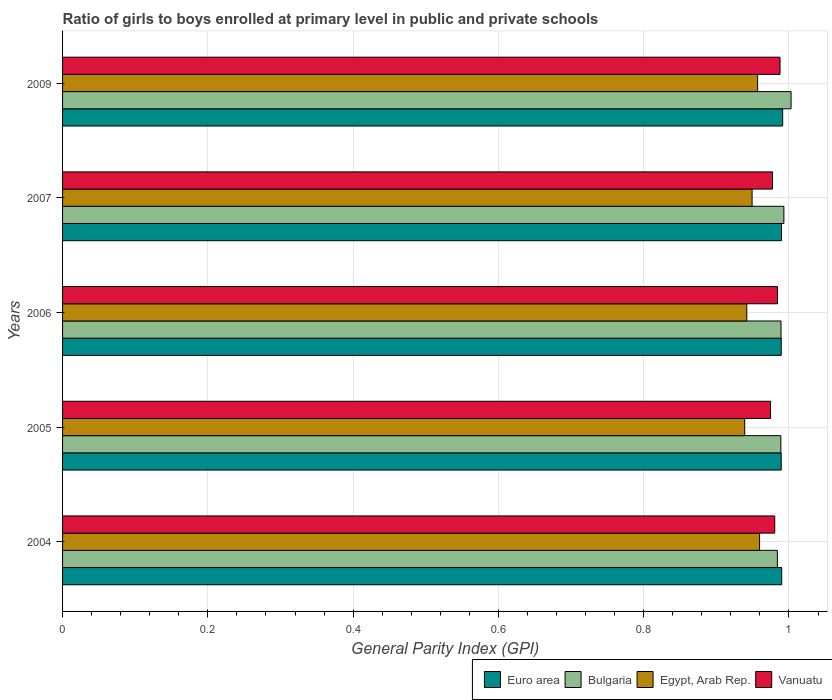How many groups of bars are there?
Offer a very short reply. 5. Are the number of bars per tick equal to the number of legend labels?
Your answer should be very brief. Yes. Are the number of bars on each tick of the Y-axis equal?
Keep it short and to the point. Yes. In how many cases, is the number of bars for a given year not equal to the number of legend labels?
Offer a terse response. 0. What is the general parity index in Bulgaria in 2007?
Your answer should be compact. 0.99. Across all years, what is the maximum general parity index in Euro area?
Offer a terse response. 0.99. Across all years, what is the minimum general parity index in Euro area?
Make the answer very short. 0.99. In which year was the general parity index in Vanuatu minimum?
Provide a short and direct response. 2005. What is the total general parity index in Egypt, Arab Rep. in the graph?
Provide a short and direct response. 4.75. What is the difference between the general parity index in Euro area in 2004 and that in 2009?
Ensure brevity in your answer.  -0. What is the difference between the general parity index in Vanuatu in 2006 and the general parity index in Bulgaria in 2007?
Provide a short and direct response. -0.01. What is the average general parity index in Euro area per year?
Provide a succinct answer. 0.99. In the year 2009, what is the difference between the general parity index in Bulgaria and general parity index in Euro area?
Your answer should be compact. 0.01. In how many years, is the general parity index in Euro area greater than 0.56 ?
Give a very brief answer. 5. What is the ratio of the general parity index in Bulgaria in 2004 to that in 2007?
Provide a succinct answer. 0.99. Is the difference between the general parity index in Bulgaria in 2005 and 2009 greater than the difference between the general parity index in Euro area in 2005 and 2009?
Ensure brevity in your answer.  No. What is the difference between the highest and the second highest general parity index in Bulgaria?
Offer a terse response. 0.01. What is the difference between the highest and the lowest general parity index in Vanuatu?
Your answer should be compact. 0.01. In how many years, is the general parity index in Egypt, Arab Rep. greater than the average general parity index in Egypt, Arab Rep. taken over all years?
Offer a terse response. 2. Is the sum of the general parity index in Bulgaria in 2004 and 2007 greater than the maximum general parity index in Egypt, Arab Rep. across all years?
Offer a very short reply. Yes. Is it the case that in every year, the sum of the general parity index in Bulgaria and general parity index in Egypt, Arab Rep. is greater than the sum of general parity index in Vanuatu and general parity index in Euro area?
Offer a terse response. No. What does the 1st bar from the top in 2005 represents?
Your answer should be very brief. Vanuatu. What does the 2nd bar from the bottom in 2006 represents?
Offer a very short reply. Bulgaria. Are all the bars in the graph horizontal?
Keep it short and to the point. Yes. What is the difference between two consecutive major ticks on the X-axis?
Ensure brevity in your answer.  0.2. Does the graph contain any zero values?
Your response must be concise. No. Does the graph contain grids?
Give a very brief answer. Yes. How many legend labels are there?
Ensure brevity in your answer.  4. What is the title of the graph?
Ensure brevity in your answer.  Ratio of girls to boys enrolled at primary level in public and private schools. Does "Korea (Democratic)" appear as one of the legend labels in the graph?
Offer a very short reply. No. What is the label or title of the X-axis?
Keep it short and to the point. General Parity Index (GPI). What is the General Parity Index (GPI) of Euro area in 2004?
Offer a very short reply. 0.99. What is the General Parity Index (GPI) of Bulgaria in 2004?
Provide a short and direct response. 0.98. What is the General Parity Index (GPI) of Egypt, Arab Rep. in 2004?
Offer a very short reply. 0.96. What is the General Parity Index (GPI) in Vanuatu in 2004?
Make the answer very short. 0.98. What is the General Parity Index (GPI) in Euro area in 2005?
Provide a succinct answer. 0.99. What is the General Parity Index (GPI) in Bulgaria in 2005?
Ensure brevity in your answer.  0.99. What is the General Parity Index (GPI) of Egypt, Arab Rep. in 2005?
Offer a very short reply. 0.94. What is the General Parity Index (GPI) in Vanuatu in 2005?
Give a very brief answer. 0.97. What is the General Parity Index (GPI) in Euro area in 2006?
Your response must be concise. 0.99. What is the General Parity Index (GPI) of Bulgaria in 2006?
Your answer should be very brief. 0.99. What is the General Parity Index (GPI) of Egypt, Arab Rep. in 2006?
Your answer should be compact. 0.94. What is the General Parity Index (GPI) in Vanuatu in 2006?
Your answer should be very brief. 0.98. What is the General Parity Index (GPI) in Euro area in 2007?
Ensure brevity in your answer.  0.99. What is the General Parity Index (GPI) of Bulgaria in 2007?
Your answer should be very brief. 0.99. What is the General Parity Index (GPI) of Egypt, Arab Rep. in 2007?
Your answer should be very brief. 0.95. What is the General Parity Index (GPI) of Vanuatu in 2007?
Your answer should be very brief. 0.98. What is the General Parity Index (GPI) of Euro area in 2009?
Offer a terse response. 0.99. What is the General Parity Index (GPI) of Bulgaria in 2009?
Offer a very short reply. 1. What is the General Parity Index (GPI) of Egypt, Arab Rep. in 2009?
Your response must be concise. 0.96. What is the General Parity Index (GPI) of Vanuatu in 2009?
Make the answer very short. 0.99. Across all years, what is the maximum General Parity Index (GPI) in Euro area?
Your response must be concise. 0.99. Across all years, what is the maximum General Parity Index (GPI) of Bulgaria?
Make the answer very short. 1. Across all years, what is the maximum General Parity Index (GPI) in Egypt, Arab Rep.?
Give a very brief answer. 0.96. Across all years, what is the maximum General Parity Index (GPI) of Vanuatu?
Offer a terse response. 0.99. Across all years, what is the minimum General Parity Index (GPI) of Euro area?
Make the answer very short. 0.99. Across all years, what is the minimum General Parity Index (GPI) in Bulgaria?
Your response must be concise. 0.98. Across all years, what is the minimum General Parity Index (GPI) in Egypt, Arab Rep.?
Provide a succinct answer. 0.94. Across all years, what is the minimum General Parity Index (GPI) of Vanuatu?
Give a very brief answer. 0.97. What is the total General Parity Index (GPI) of Euro area in the graph?
Your answer should be compact. 4.95. What is the total General Parity Index (GPI) in Bulgaria in the graph?
Your response must be concise. 4.96. What is the total General Parity Index (GPI) of Egypt, Arab Rep. in the graph?
Your answer should be very brief. 4.75. What is the total General Parity Index (GPI) in Vanuatu in the graph?
Keep it short and to the point. 4.9. What is the difference between the General Parity Index (GPI) in Euro area in 2004 and that in 2005?
Make the answer very short. 0. What is the difference between the General Parity Index (GPI) in Bulgaria in 2004 and that in 2005?
Give a very brief answer. -0. What is the difference between the General Parity Index (GPI) in Egypt, Arab Rep. in 2004 and that in 2005?
Keep it short and to the point. 0.02. What is the difference between the General Parity Index (GPI) in Vanuatu in 2004 and that in 2005?
Offer a terse response. 0.01. What is the difference between the General Parity Index (GPI) of Euro area in 2004 and that in 2006?
Make the answer very short. 0. What is the difference between the General Parity Index (GPI) in Bulgaria in 2004 and that in 2006?
Your answer should be compact. -0.01. What is the difference between the General Parity Index (GPI) in Egypt, Arab Rep. in 2004 and that in 2006?
Your answer should be compact. 0.02. What is the difference between the General Parity Index (GPI) in Vanuatu in 2004 and that in 2006?
Your response must be concise. -0. What is the difference between the General Parity Index (GPI) in Bulgaria in 2004 and that in 2007?
Keep it short and to the point. -0.01. What is the difference between the General Parity Index (GPI) in Egypt, Arab Rep. in 2004 and that in 2007?
Make the answer very short. 0.01. What is the difference between the General Parity Index (GPI) in Vanuatu in 2004 and that in 2007?
Keep it short and to the point. 0. What is the difference between the General Parity Index (GPI) in Euro area in 2004 and that in 2009?
Your answer should be very brief. -0. What is the difference between the General Parity Index (GPI) of Bulgaria in 2004 and that in 2009?
Your answer should be very brief. -0.02. What is the difference between the General Parity Index (GPI) of Egypt, Arab Rep. in 2004 and that in 2009?
Ensure brevity in your answer.  0. What is the difference between the General Parity Index (GPI) in Vanuatu in 2004 and that in 2009?
Your answer should be compact. -0.01. What is the difference between the General Parity Index (GPI) in Euro area in 2005 and that in 2006?
Offer a terse response. -0. What is the difference between the General Parity Index (GPI) in Bulgaria in 2005 and that in 2006?
Keep it short and to the point. -0. What is the difference between the General Parity Index (GPI) in Egypt, Arab Rep. in 2005 and that in 2006?
Offer a very short reply. -0. What is the difference between the General Parity Index (GPI) of Vanuatu in 2005 and that in 2006?
Give a very brief answer. -0.01. What is the difference between the General Parity Index (GPI) in Euro area in 2005 and that in 2007?
Make the answer very short. -0. What is the difference between the General Parity Index (GPI) in Bulgaria in 2005 and that in 2007?
Make the answer very short. -0. What is the difference between the General Parity Index (GPI) in Egypt, Arab Rep. in 2005 and that in 2007?
Give a very brief answer. -0.01. What is the difference between the General Parity Index (GPI) of Vanuatu in 2005 and that in 2007?
Your answer should be compact. -0. What is the difference between the General Parity Index (GPI) of Euro area in 2005 and that in 2009?
Provide a short and direct response. -0. What is the difference between the General Parity Index (GPI) of Bulgaria in 2005 and that in 2009?
Your answer should be compact. -0.01. What is the difference between the General Parity Index (GPI) in Egypt, Arab Rep. in 2005 and that in 2009?
Your response must be concise. -0.02. What is the difference between the General Parity Index (GPI) of Vanuatu in 2005 and that in 2009?
Offer a terse response. -0.01. What is the difference between the General Parity Index (GPI) in Euro area in 2006 and that in 2007?
Make the answer very short. -0. What is the difference between the General Parity Index (GPI) of Bulgaria in 2006 and that in 2007?
Offer a terse response. -0. What is the difference between the General Parity Index (GPI) of Egypt, Arab Rep. in 2006 and that in 2007?
Offer a very short reply. -0.01. What is the difference between the General Parity Index (GPI) of Vanuatu in 2006 and that in 2007?
Your answer should be very brief. 0.01. What is the difference between the General Parity Index (GPI) of Euro area in 2006 and that in 2009?
Offer a very short reply. -0. What is the difference between the General Parity Index (GPI) of Bulgaria in 2006 and that in 2009?
Keep it short and to the point. -0.01. What is the difference between the General Parity Index (GPI) of Egypt, Arab Rep. in 2006 and that in 2009?
Provide a succinct answer. -0.01. What is the difference between the General Parity Index (GPI) of Vanuatu in 2006 and that in 2009?
Offer a very short reply. -0. What is the difference between the General Parity Index (GPI) of Euro area in 2007 and that in 2009?
Provide a short and direct response. -0. What is the difference between the General Parity Index (GPI) of Bulgaria in 2007 and that in 2009?
Provide a succinct answer. -0.01. What is the difference between the General Parity Index (GPI) of Egypt, Arab Rep. in 2007 and that in 2009?
Provide a short and direct response. -0.01. What is the difference between the General Parity Index (GPI) of Vanuatu in 2007 and that in 2009?
Your answer should be very brief. -0.01. What is the difference between the General Parity Index (GPI) of Euro area in 2004 and the General Parity Index (GPI) of Bulgaria in 2005?
Make the answer very short. 0. What is the difference between the General Parity Index (GPI) in Euro area in 2004 and the General Parity Index (GPI) in Egypt, Arab Rep. in 2005?
Ensure brevity in your answer.  0.05. What is the difference between the General Parity Index (GPI) in Euro area in 2004 and the General Parity Index (GPI) in Vanuatu in 2005?
Make the answer very short. 0.02. What is the difference between the General Parity Index (GPI) of Bulgaria in 2004 and the General Parity Index (GPI) of Egypt, Arab Rep. in 2005?
Offer a terse response. 0.04. What is the difference between the General Parity Index (GPI) of Bulgaria in 2004 and the General Parity Index (GPI) of Vanuatu in 2005?
Keep it short and to the point. 0.01. What is the difference between the General Parity Index (GPI) of Egypt, Arab Rep. in 2004 and the General Parity Index (GPI) of Vanuatu in 2005?
Keep it short and to the point. -0.02. What is the difference between the General Parity Index (GPI) in Euro area in 2004 and the General Parity Index (GPI) in Bulgaria in 2006?
Your response must be concise. 0. What is the difference between the General Parity Index (GPI) in Euro area in 2004 and the General Parity Index (GPI) in Egypt, Arab Rep. in 2006?
Ensure brevity in your answer.  0.05. What is the difference between the General Parity Index (GPI) of Euro area in 2004 and the General Parity Index (GPI) of Vanuatu in 2006?
Provide a short and direct response. 0.01. What is the difference between the General Parity Index (GPI) in Bulgaria in 2004 and the General Parity Index (GPI) in Egypt, Arab Rep. in 2006?
Your answer should be compact. 0.04. What is the difference between the General Parity Index (GPI) in Bulgaria in 2004 and the General Parity Index (GPI) in Vanuatu in 2006?
Your answer should be very brief. -0. What is the difference between the General Parity Index (GPI) in Egypt, Arab Rep. in 2004 and the General Parity Index (GPI) in Vanuatu in 2006?
Offer a terse response. -0.02. What is the difference between the General Parity Index (GPI) of Euro area in 2004 and the General Parity Index (GPI) of Bulgaria in 2007?
Keep it short and to the point. -0. What is the difference between the General Parity Index (GPI) of Euro area in 2004 and the General Parity Index (GPI) of Egypt, Arab Rep. in 2007?
Your response must be concise. 0.04. What is the difference between the General Parity Index (GPI) of Euro area in 2004 and the General Parity Index (GPI) of Vanuatu in 2007?
Your answer should be very brief. 0.01. What is the difference between the General Parity Index (GPI) in Bulgaria in 2004 and the General Parity Index (GPI) in Egypt, Arab Rep. in 2007?
Ensure brevity in your answer.  0.03. What is the difference between the General Parity Index (GPI) in Bulgaria in 2004 and the General Parity Index (GPI) in Vanuatu in 2007?
Your answer should be compact. 0.01. What is the difference between the General Parity Index (GPI) of Egypt, Arab Rep. in 2004 and the General Parity Index (GPI) of Vanuatu in 2007?
Offer a terse response. -0.02. What is the difference between the General Parity Index (GPI) in Euro area in 2004 and the General Parity Index (GPI) in Bulgaria in 2009?
Your answer should be very brief. -0.01. What is the difference between the General Parity Index (GPI) in Euro area in 2004 and the General Parity Index (GPI) in Egypt, Arab Rep. in 2009?
Your answer should be compact. 0.03. What is the difference between the General Parity Index (GPI) in Euro area in 2004 and the General Parity Index (GPI) in Vanuatu in 2009?
Offer a terse response. 0. What is the difference between the General Parity Index (GPI) in Bulgaria in 2004 and the General Parity Index (GPI) in Egypt, Arab Rep. in 2009?
Ensure brevity in your answer.  0.03. What is the difference between the General Parity Index (GPI) of Bulgaria in 2004 and the General Parity Index (GPI) of Vanuatu in 2009?
Make the answer very short. -0. What is the difference between the General Parity Index (GPI) of Egypt, Arab Rep. in 2004 and the General Parity Index (GPI) of Vanuatu in 2009?
Make the answer very short. -0.03. What is the difference between the General Parity Index (GPI) in Euro area in 2005 and the General Parity Index (GPI) in Bulgaria in 2006?
Make the answer very short. 0. What is the difference between the General Parity Index (GPI) of Euro area in 2005 and the General Parity Index (GPI) of Egypt, Arab Rep. in 2006?
Make the answer very short. 0.05. What is the difference between the General Parity Index (GPI) in Euro area in 2005 and the General Parity Index (GPI) in Vanuatu in 2006?
Provide a short and direct response. 0.01. What is the difference between the General Parity Index (GPI) of Bulgaria in 2005 and the General Parity Index (GPI) of Egypt, Arab Rep. in 2006?
Your answer should be compact. 0.05. What is the difference between the General Parity Index (GPI) of Bulgaria in 2005 and the General Parity Index (GPI) of Vanuatu in 2006?
Your answer should be compact. 0. What is the difference between the General Parity Index (GPI) of Egypt, Arab Rep. in 2005 and the General Parity Index (GPI) of Vanuatu in 2006?
Offer a terse response. -0.05. What is the difference between the General Parity Index (GPI) of Euro area in 2005 and the General Parity Index (GPI) of Bulgaria in 2007?
Provide a short and direct response. -0. What is the difference between the General Parity Index (GPI) of Euro area in 2005 and the General Parity Index (GPI) of Egypt, Arab Rep. in 2007?
Make the answer very short. 0.04. What is the difference between the General Parity Index (GPI) of Euro area in 2005 and the General Parity Index (GPI) of Vanuatu in 2007?
Give a very brief answer. 0.01. What is the difference between the General Parity Index (GPI) of Bulgaria in 2005 and the General Parity Index (GPI) of Egypt, Arab Rep. in 2007?
Offer a terse response. 0.04. What is the difference between the General Parity Index (GPI) in Bulgaria in 2005 and the General Parity Index (GPI) in Vanuatu in 2007?
Your response must be concise. 0.01. What is the difference between the General Parity Index (GPI) of Egypt, Arab Rep. in 2005 and the General Parity Index (GPI) of Vanuatu in 2007?
Your answer should be very brief. -0.04. What is the difference between the General Parity Index (GPI) in Euro area in 2005 and the General Parity Index (GPI) in Bulgaria in 2009?
Provide a short and direct response. -0.01. What is the difference between the General Parity Index (GPI) in Euro area in 2005 and the General Parity Index (GPI) in Egypt, Arab Rep. in 2009?
Offer a very short reply. 0.03. What is the difference between the General Parity Index (GPI) of Euro area in 2005 and the General Parity Index (GPI) of Vanuatu in 2009?
Make the answer very short. 0. What is the difference between the General Parity Index (GPI) of Bulgaria in 2005 and the General Parity Index (GPI) of Egypt, Arab Rep. in 2009?
Your response must be concise. 0.03. What is the difference between the General Parity Index (GPI) of Bulgaria in 2005 and the General Parity Index (GPI) of Vanuatu in 2009?
Your response must be concise. 0. What is the difference between the General Parity Index (GPI) in Egypt, Arab Rep. in 2005 and the General Parity Index (GPI) in Vanuatu in 2009?
Offer a terse response. -0.05. What is the difference between the General Parity Index (GPI) of Euro area in 2006 and the General Parity Index (GPI) of Bulgaria in 2007?
Offer a terse response. -0. What is the difference between the General Parity Index (GPI) in Euro area in 2006 and the General Parity Index (GPI) in Egypt, Arab Rep. in 2007?
Give a very brief answer. 0.04. What is the difference between the General Parity Index (GPI) in Euro area in 2006 and the General Parity Index (GPI) in Vanuatu in 2007?
Ensure brevity in your answer.  0.01. What is the difference between the General Parity Index (GPI) of Bulgaria in 2006 and the General Parity Index (GPI) of Egypt, Arab Rep. in 2007?
Your answer should be very brief. 0.04. What is the difference between the General Parity Index (GPI) of Bulgaria in 2006 and the General Parity Index (GPI) of Vanuatu in 2007?
Make the answer very short. 0.01. What is the difference between the General Parity Index (GPI) in Egypt, Arab Rep. in 2006 and the General Parity Index (GPI) in Vanuatu in 2007?
Your answer should be very brief. -0.04. What is the difference between the General Parity Index (GPI) of Euro area in 2006 and the General Parity Index (GPI) of Bulgaria in 2009?
Keep it short and to the point. -0.01. What is the difference between the General Parity Index (GPI) of Euro area in 2006 and the General Parity Index (GPI) of Egypt, Arab Rep. in 2009?
Make the answer very short. 0.03. What is the difference between the General Parity Index (GPI) of Euro area in 2006 and the General Parity Index (GPI) of Vanuatu in 2009?
Provide a succinct answer. 0. What is the difference between the General Parity Index (GPI) in Bulgaria in 2006 and the General Parity Index (GPI) in Egypt, Arab Rep. in 2009?
Give a very brief answer. 0.03. What is the difference between the General Parity Index (GPI) in Bulgaria in 2006 and the General Parity Index (GPI) in Vanuatu in 2009?
Give a very brief answer. 0. What is the difference between the General Parity Index (GPI) in Egypt, Arab Rep. in 2006 and the General Parity Index (GPI) in Vanuatu in 2009?
Give a very brief answer. -0.05. What is the difference between the General Parity Index (GPI) in Euro area in 2007 and the General Parity Index (GPI) in Bulgaria in 2009?
Offer a terse response. -0.01. What is the difference between the General Parity Index (GPI) of Euro area in 2007 and the General Parity Index (GPI) of Egypt, Arab Rep. in 2009?
Give a very brief answer. 0.03. What is the difference between the General Parity Index (GPI) of Euro area in 2007 and the General Parity Index (GPI) of Vanuatu in 2009?
Offer a terse response. 0. What is the difference between the General Parity Index (GPI) in Bulgaria in 2007 and the General Parity Index (GPI) in Egypt, Arab Rep. in 2009?
Provide a short and direct response. 0.04. What is the difference between the General Parity Index (GPI) in Bulgaria in 2007 and the General Parity Index (GPI) in Vanuatu in 2009?
Your response must be concise. 0.01. What is the difference between the General Parity Index (GPI) in Egypt, Arab Rep. in 2007 and the General Parity Index (GPI) in Vanuatu in 2009?
Provide a succinct answer. -0.04. What is the average General Parity Index (GPI) of Euro area per year?
Keep it short and to the point. 0.99. What is the average General Parity Index (GPI) of Bulgaria per year?
Offer a very short reply. 0.99. What is the average General Parity Index (GPI) in Egypt, Arab Rep. per year?
Provide a succinct answer. 0.95. What is the average General Parity Index (GPI) of Vanuatu per year?
Your answer should be very brief. 0.98. In the year 2004, what is the difference between the General Parity Index (GPI) of Euro area and General Parity Index (GPI) of Bulgaria?
Give a very brief answer. 0.01. In the year 2004, what is the difference between the General Parity Index (GPI) of Euro area and General Parity Index (GPI) of Egypt, Arab Rep.?
Ensure brevity in your answer.  0.03. In the year 2004, what is the difference between the General Parity Index (GPI) of Euro area and General Parity Index (GPI) of Vanuatu?
Your response must be concise. 0.01. In the year 2004, what is the difference between the General Parity Index (GPI) of Bulgaria and General Parity Index (GPI) of Egypt, Arab Rep.?
Keep it short and to the point. 0.02. In the year 2004, what is the difference between the General Parity Index (GPI) in Bulgaria and General Parity Index (GPI) in Vanuatu?
Ensure brevity in your answer.  0. In the year 2004, what is the difference between the General Parity Index (GPI) of Egypt, Arab Rep. and General Parity Index (GPI) of Vanuatu?
Give a very brief answer. -0.02. In the year 2005, what is the difference between the General Parity Index (GPI) in Euro area and General Parity Index (GPI) in Bulgaria?
Your response must be concise. 0. In the year 2005, what is the difference between the General Parity Index (GPI) in Euro area and General Parity Index (GPI) in Egypt, Arab Rep.?
Your answer should be compact. 0.05. In the year 2005, what is the difference between the General Parity Index (GPI) in Euro area and General Parity Index (GPI) in Vanuatu?
Your answer should be very brief. 0.01. In the year 2005, what is the difference between the General Parity Index (GPI) of Bulgaria and General Parity Index (GPI) of Egypt, Arab Rep.?
Provide a succinct answer. 0.05. In the year 2005, what is the difference between the General Parity Index (GPI) of Bulgaria and General Parity Index (GPI) of Vanuatu?
Ensure brevity in your answer.  0.01. In the year 2005, what is the difference between the General Parity Index (GPI) of Egypt, Arab Rep. and General Parity Index (GPI) of Vanuatu?
Offer a very short reply. -0.04. In the year 2006, what is the difference between the General Parity Index (GPI) of Euro area and General Parity Index (GPI) of Egypt, Arab Rep.?
Provide a succinct answer. 0.05. In the year 2006, what is the difference between the General Parity Index (GPI) of Euro area and General Parity Index (GPI) of Vanuatu?
Offer a terse response. 0.01. In the year 2006, what is the difference between the General Parity Index (GPI) in Bulgaria and General Parity Index (GPI) in Egypt, Arab Rep.?
Offer a very short reply. 0.05. In the year 2006, what is the difference between the General Parity Index (GPI) of Bulgaria and General Parity Index (GPI) of Vanuatu?
Offer a terse response. 0. In the year 2006, what is the difference between the General Parity Index (GPI) of Egypt, Arab Rep. and General Parity Index (GPI) of Vanuatu?
Your answer should be compact. -0.04. In the year 2007, what is the difference between the General Parity Index (GPI) of Euro area and General Parity Index (GPI) of Bulgaria?
Your answer should be very brief. -0. In the year 2007, what is the difference between the General Parity Index (GPI) in Euro area and General Parity Index (GPI) in Egypt, Arab Rep.?
Keep it short and to the point. 0.04. In the year 2007, what is the difference between the General Parity Index (GPI) of Euro area and General Parity Index (GPI) of Vanuatu?
Make the answer very short. 0.01. In the year 2007, what is the difference between the General Parity Index (GPI) of Bulgaria and General Parity Index (GPI) of Egypt, Arab Rep.?
Offer a terse response. 0.04. In the year 2007, what is the difference between the General Parity Index (GPI) of Bulgaria and General Parity Index (GPI) of Vanuatu?
Your answer should be very brief. 0.02. In the year 2007, what is the difference between the General Parity Index (GPI) in Egypt, Arab Rep. and General Parity Index (GPI) in Vanuatu?
Your answer should be compact. -0.03. In the year 2009, what is the difference between the General Parity Index (GPI) in Euro area and General Parity Index (GPI) in Bulgaria?
Offer a very short reply. -0.01. In the year 2009, what is the difference between the General Parity Index (GPI) in Euro area and General Parity Index (GPI) in Egypt, Arab Rep.?
Offer a terse response. 0.03. In the year 2009, what is the difference between the General Parity Index (GPI) in Euro area and General Parity Index (GPI) in Vanuatu?
Offer a very short reply. 0. In the year 2009, what is the difference between the General Parity Index (GPI) in Bulgaria and General Parity Index (GPI) in Egypt, Arab Rep.?
Your answer should be very brief. 0.05. In the year 2009, what is the difference between the General Parity Index (GPI) in Bulgaria and General Parity Index (GPI) in Vanuatu?
Your response must be concise. 0.02. In the year 2009, what is the difference between the General Parity Index (GPI) in Egypt, Arab Rep. and General Parity Index (GPI) in Vanuatu?
Give a very brief answer. -0.03. What is the ratio of the General Parity Index (GPI) of Euro area in 2004 to that in 2005?
Make the answer very short. 1. What is the ratio of the General Parity Index (GPI) in Bulgaria in 2004 to that in 2005?
Offer a terse response. 1. What is the ratio of the General Parity Index (GPI) of Egypt, Arab Rep. in 2004 to that in 2005?
Make the answer very short. 1.02. What is the ratio of the General Parity Index (GPI) of Vanuatu in 2004 to that in 2005?
Your answer should be very brief. 1.01. What is the ratio of the General Parity Index (GPI) in Euro area in 2004 to that in 2006?
Give a very brief answer. 1. What is the ratio of the General Parity Index (GPI) of Egypt, Arab Rep. in 2004 to that in 2006?
Keep it short and to the point. 1.02. What is the ratio of the General Parity Index (GPI) of Vanuatu in 2004 to that in 2006?
Keep it short and to the point. 1. What is the ratio of the General Parity Index (GPI) of Euro area in 2004 to that in 2007?
Ensure brevity in your answer.  1. What is the ratio of the General Parity Index (GPI) in Egypt, Arab Rep. in 2004 to that in 2007?
Make the answer very short. 1.01. What is the ratio of the General Parity Index (GPI) in Vanuatu in 2004 to that in 2007?
Provide a short and direct response. 1. What is the ratio of the General Parity Index (GPI) in Euro area in 2004 to that in 2009?
Keep it short and to the point. 1. What is the ratio of the General Parity Index (GPI) of Bulgaria in 2004 to that in 2009?
Keep it short and to the point. 0.98. What is the ratio of the General Parity Index (GPI) in Vanuatu in 2004 to that in 2009?
Offer a very short reply. 0.99. What is the ratio of the General Parity Index (GPI) of Euro area in 2005 to that in 2006?
Provide a short and direct response. 1. What is the ratio of the General Parity Index (GPI) in Vanuatu in 2005 to that in 2006?
Make the answer very short. 0.99. What is the ratio of the General Parity Index (GPI) in Euro area in 2005 to that in 2007?
Provide a short and direct response. 1. What is the ratio of the General Parity Index (GPI) of Egypt, Arab Rep. in 2005 to that in 2007?
Give a very brief answer. 0.99. What is the ratio of the General Parity Index (GPI) in Vanuatu in 2005 to that in 2007?
Your answer should be very brief. 1. What is the ratio of the General Parity Index (GPI) of Euro area in 2005 to that in 2009?
Offer a very short reply. 1. What is the ratio of the General Parity Index (GPI) of Bulgaria in 2005 to that in 2009?
Provide a succinct answer. 0.99. What is the ratio of the General Parity Index (GPI) in Egypt, Arab Rep. in 2005 to that in 2009?
Make the answer very short. 0.98. What is the ratio of the General Parity Index (GPI) in Bulgaria in 2006 to that in 2007?
Your response must be concise. 1. What is the ratio of the General Parity Index (GPI) of Egypt, Arab Rep. in 2006 to that in 2007?
Your answer should be very brief. 0.99. What is the ratio of the General Parity Index (GPI) in Euro area in 2006 to that in 2009?
Your answer should be compact. 1. What is the ratio of the General Parity Index (GPI) of Bulgaria in 2006 to that in 2009?
Offer a very short reply. 0.99. What is the ratio of the General Parity Index (GPI) of Egypt, Arab Rep. in 2006 to that in 2009?
Your response must be concise. 0.98. What is the ratio of the General Parity Index (GPI) of Vanuatu in 2006 to that in 2009?
Provide a short and direct response. 1. What is the ratio of the General Parity Index (GPI) of Euro area in 2007 to that in 2009?
Offer a very short reply. 1. What is the ratio of the General Parity Index (GPI) in Bulgaria in 2007 to that in 2009?
Ensure brevity in your answer.  0.99. What is the ratio of the General Parity Index (GPI) in Egypt, Arab Rep. in 2007 to that in 2009?
Offer a very short reply. 0.99. What is the ratio of the General Parity Index (GPI) of Vanuatu in 2007 to that in 2009?
Make the answer very short. 0.99. What is the difference between the highest and the second highest General Parity Index (GPI) of Euro area?
Offer a terse response. 0. What is the difference between the highest and the second highest General Parity Index (GPI) of Bulgaria?
Offer a very short reply. 0.01. What is the difference between the highest and the second highest General Parity Index (GPI) in Egypt, Arab Rep.?
Offer a very short reply. 0. What is the difference between the highest and the second highest General Parity Index (GPI) in Vanuatu?
Your answer should be compact. 0. What is the difference between the highest and the lowest General Parity Index (GPI) in Euro area?
Offer a very short reply. 0. What is the difference between the highest and the lowest General Parity Index (GPI) in Bulgaria?
Provide a short and direct response. 0.02. What is the difference between the highest and the lowest General Parity Index (GPI) in Egypt, Arab Rep.?
Offer a very short reply. 0.02. What is the difference between the highest and the lowest General Parity Index (GPI) of Vanuatu?
Provide a short and direct response. 0.01. 